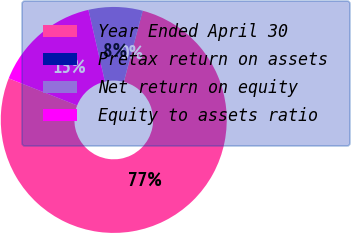Convert chart to OTSL. <chart><loc_0><loc_0><loc_500><loc_500><pie_chart><fcel>Year Ended April 30<fcel>Pretax return on assets<fcel>Net return on equity<fcel>Equity to assets ratio<nl><fcel>76.86%<fcel>0.03%<fcel>7.71%<fcel>15.4%<nl></chart> 